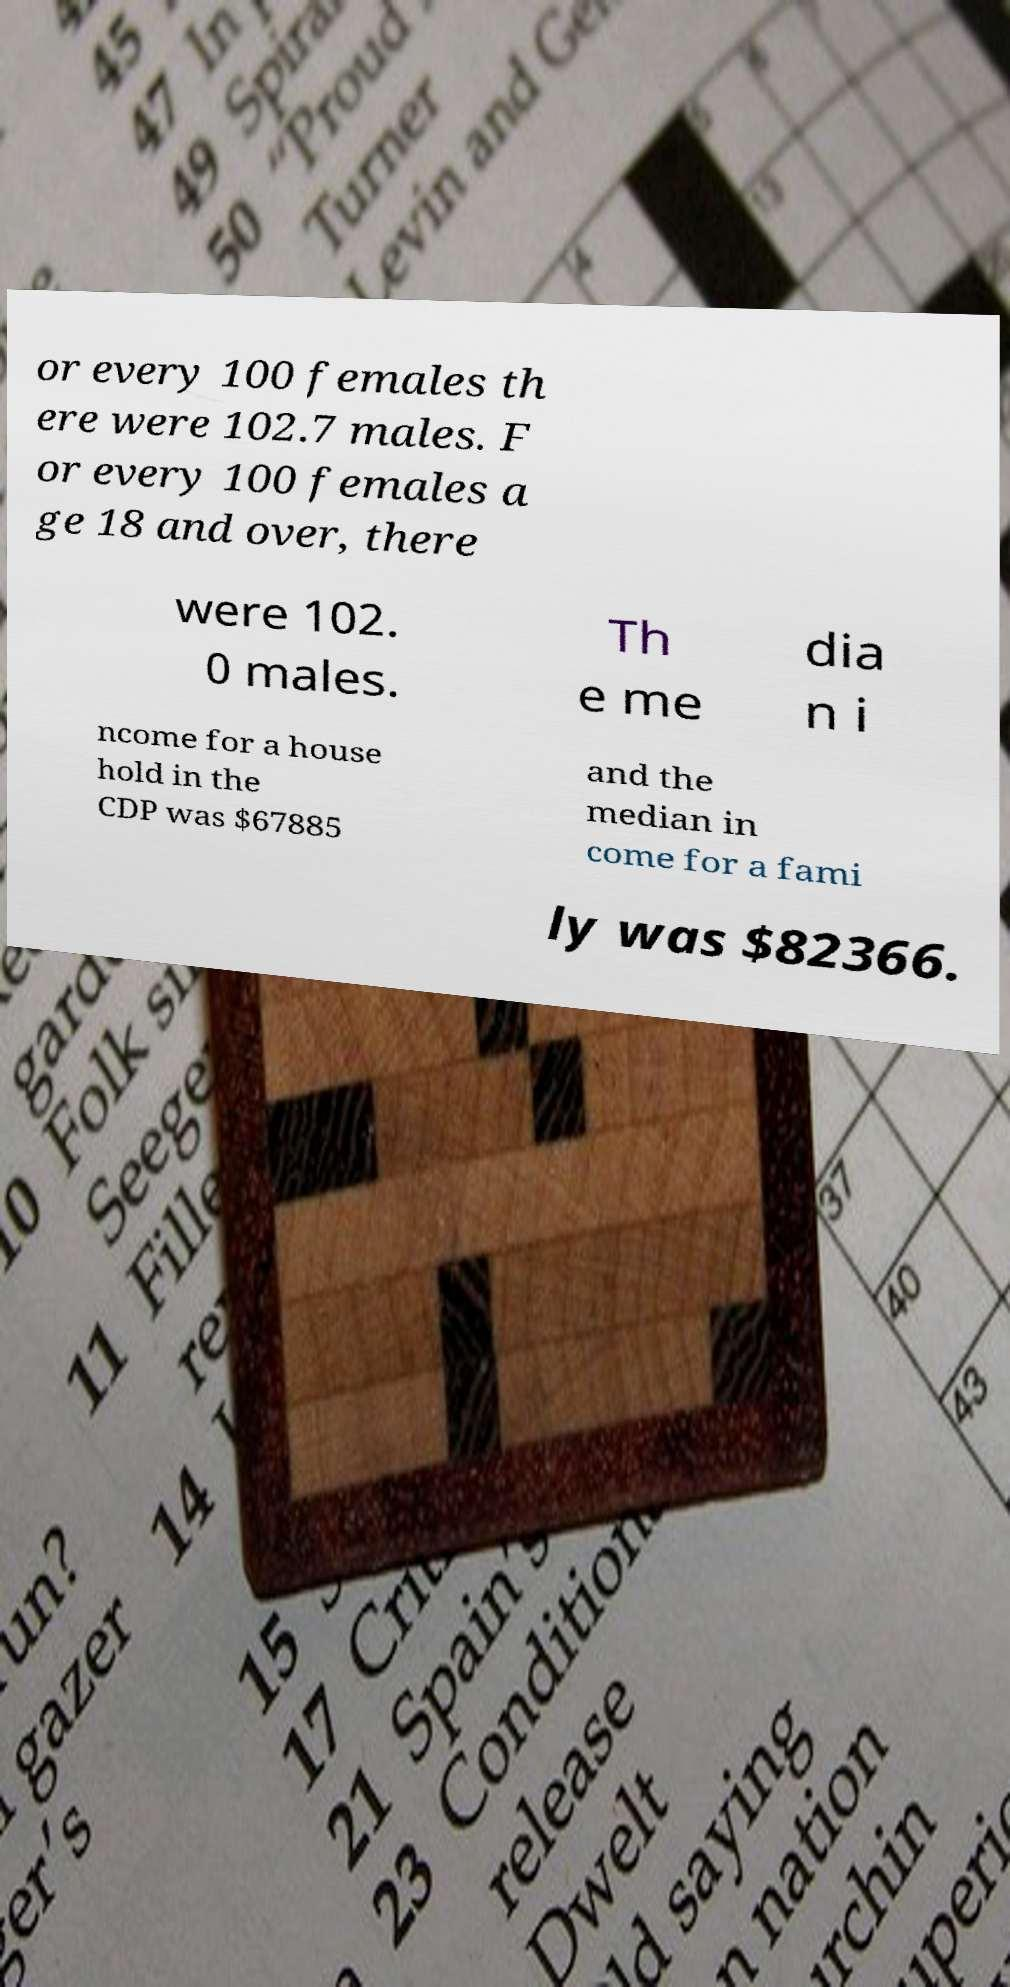There's text embedded in this image that I need extracted. Can you transcribe it verbatim? or every 100 females th ere were 102.7 males. F or every 100 females a ge 18 and over, there were 102. 0 males. Th e me dia n i ncome for a house hold in the CDP was $67885 and the median in come for a fami ly was $82366. 